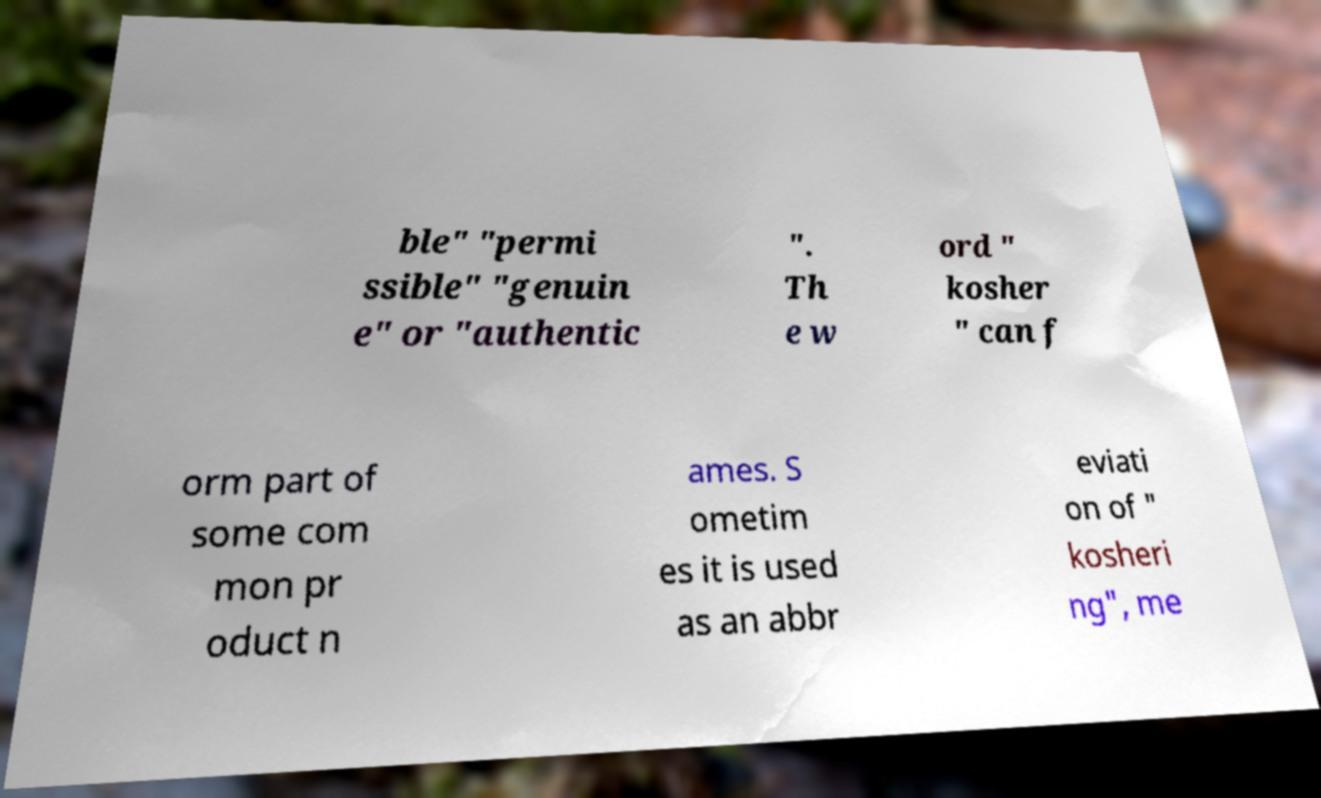Please read and relay the text visible in this image. What does it say? ble" "permi ssible" "genuin e" or "authentic ". Th e w ord " kosher " can f orm part of some com mon pr oduct n ames. S ometim es it is used as an abbr eviati on of " kosheri ng", me 